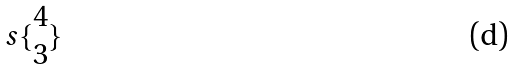<formula> <loc_0><loc_0><loc_500><loc_500>s \{ \begin{matrix} 4 \\ 3 \end{matrix} \}</formula> 